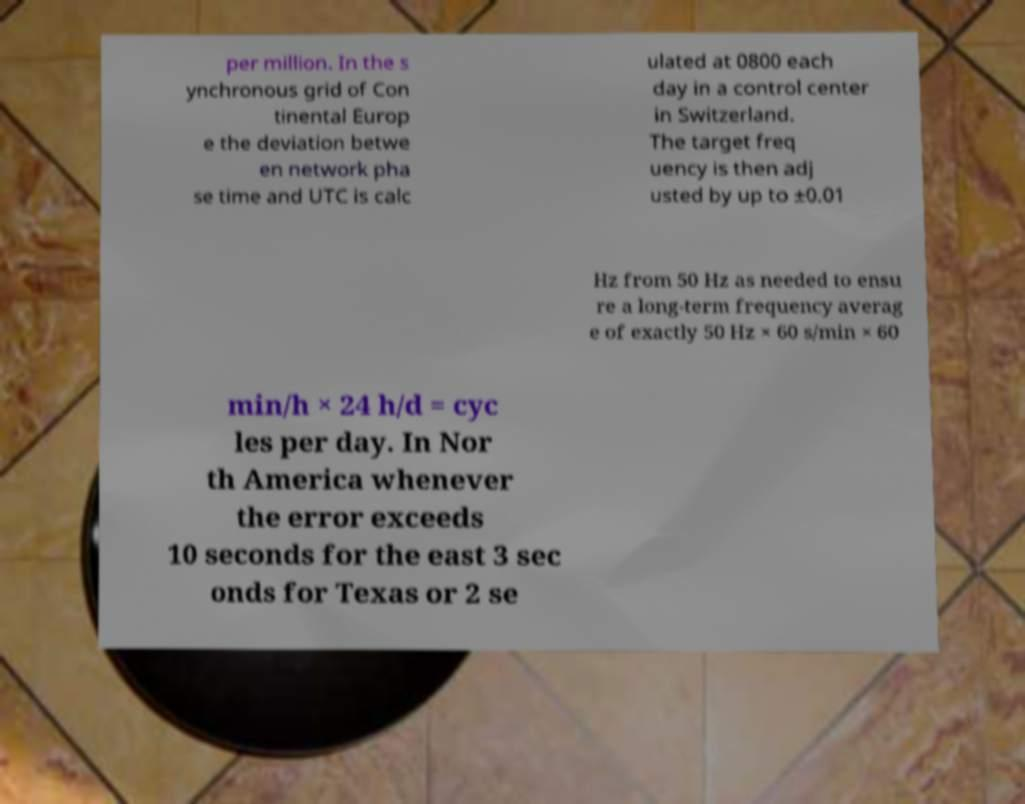I need the written content from this picture converted into text. Can you do that? per million. In the s ynchronous grid of Con tinental Europ e the deviation betwe en network pha se time and UTC is calc ulated at 0800 each day in a control center in Switzerland. The target freq uency is then adj usted by up to ±0.01 Hz from 50 Hz as needed to ensu re a long-term frequency averag e of exactly 50 Hz × 60 s/min × 60 min/h × 24 h/d = cyc les per day. In Nor th America whenever the error exceeds 10 seconds for the east 3 sec onds for Texas or 2 se 